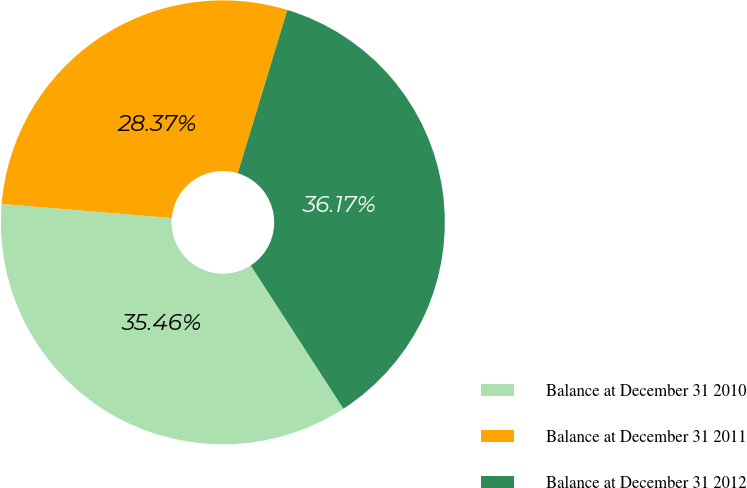Convert chart. <chart><loc_0><loc_0><loc_500><loc_500><pie_chart><fcel>Balance at December 31 2010<fcel>Balance at December 31 2011<fcel>Balance at December 31 2012<nl><fcel>35.46%<fcel>28.37%<fcel>36.17%<nl></chart> 